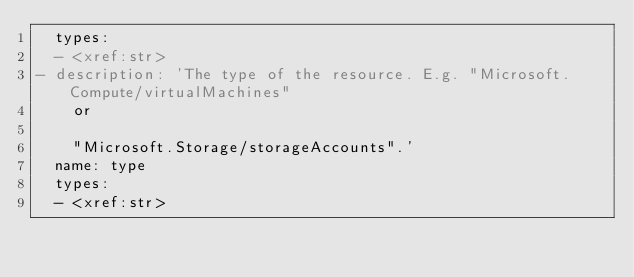Convert code to text. <code><loc_0><loc_0><loc_500><loc_500><_YAML_>  types:
  - <xref:str>
- description: 'The type of the resource. E.g. "Microsoft.Compute/virtualMachines"
    or

    "Microsoft.Storage/storageAccounts".'
  name: type
  types:
  - <xref:str>
</code> 